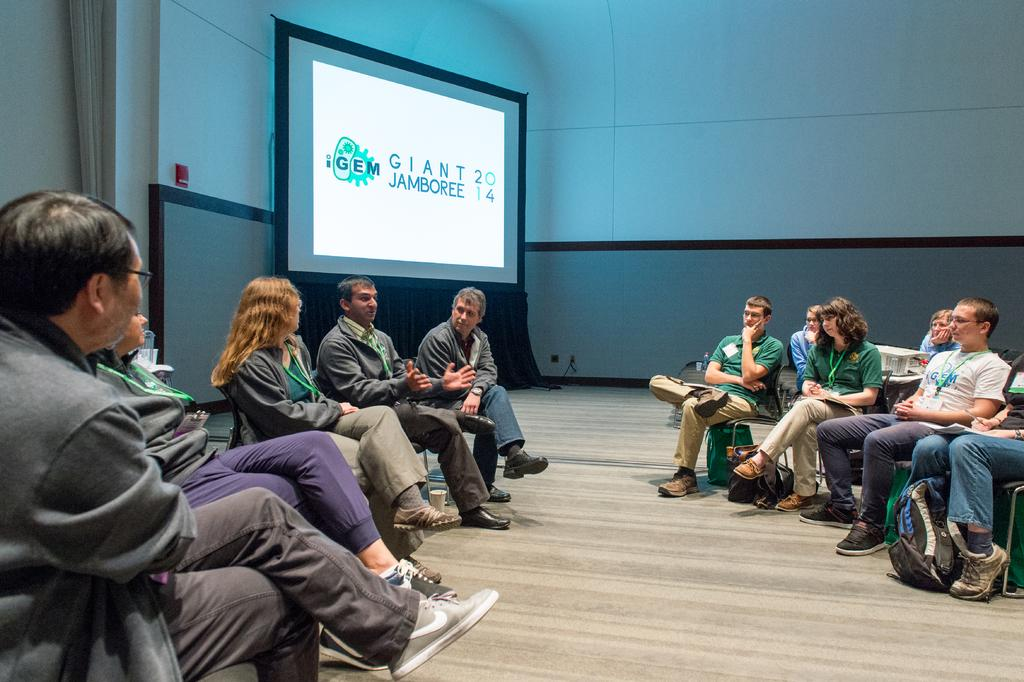What are the people in the image doing? The people in the image are sitting on chairs. What can be seen in the background of the image? There is a wall and a screen with projected text visible in the background of the image. Can you see any ghosts interacting with the people in the image? There are no ghosts present in the image. Are there any slaves visible in the image? The term "slave" is not relevant to the image, as it does not depict any historical or contemporary context related to slavery. 